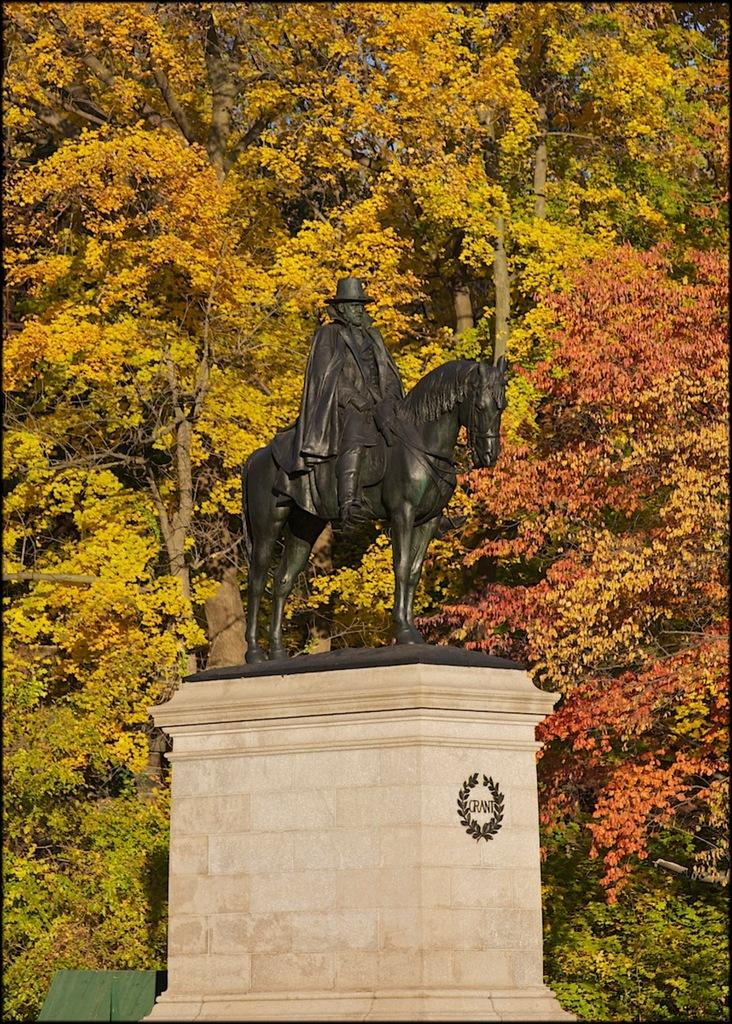What is the person in the image doing? The person is sitting on a horse sculpture in the image. What can be seen in the background of the image? There are trees visible in the image. What is the mom discussing with the person in the image? There is no mom or discussion present in the image; it only features a person sitting on a horse sculpture and trees in the background. 